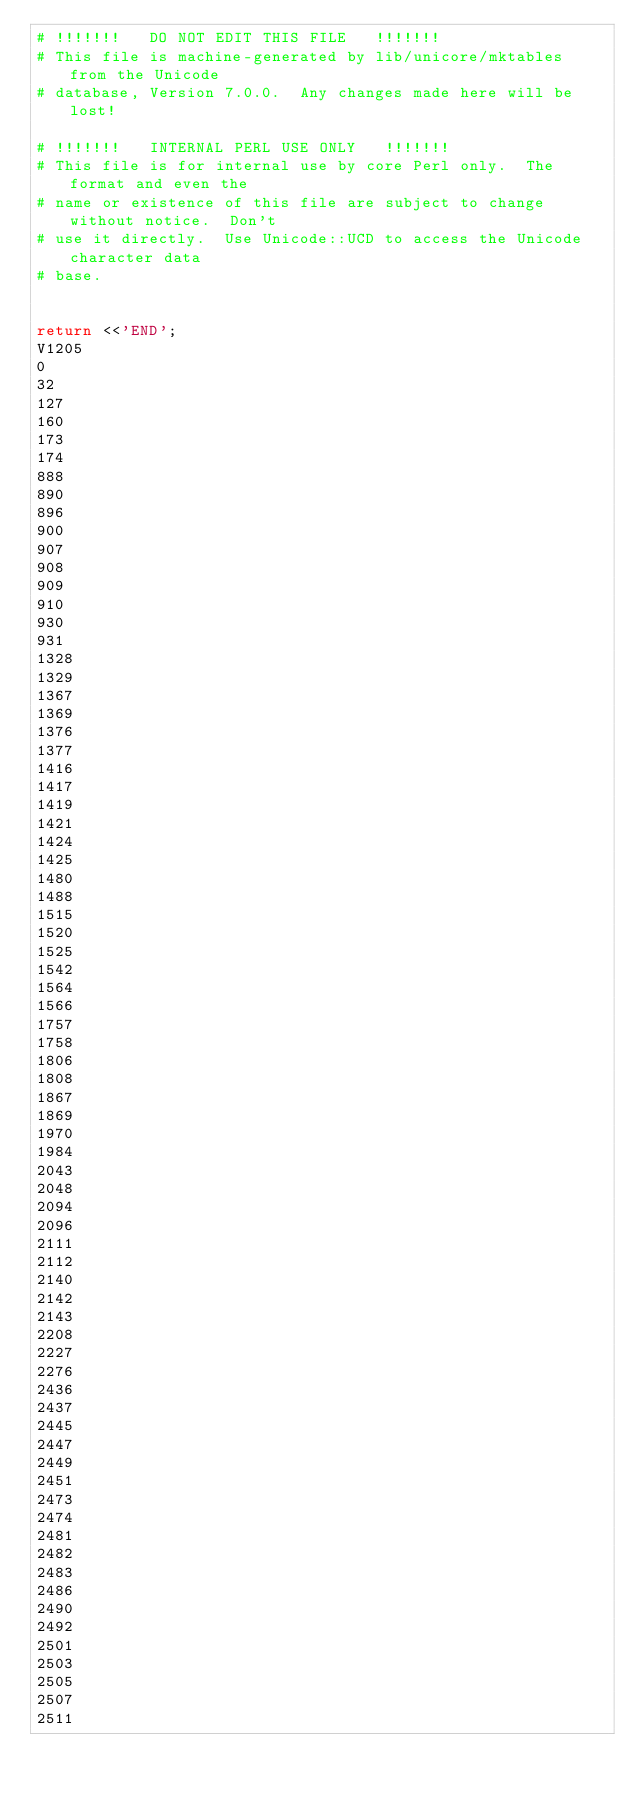<code> <loc_0><loc_0><loc_500><loc_500><_Perl_># !!!!!!!   DO NOT EDIT THIS FILE   !!!!!!!
# This file is machine-generated by lib/unicore/mktables from the Unicode
# database, Version 7.0.0.  Any changes made here will be lost!

# !!!!!!!   INTERNAL PERL USE ONLY   !!!!!!!
# This file is for internal use by core Perl only.  The format and even the
# name or existence of this file are subject to change without notice.  Don't
# use it directly.  Use Unicode::UCD to access the Unicode character data
# base.


return <<'END';
V1205
0
32
127
160
173
174
888
890
896
900
907
908
909
910
930
931
1328
1329
1367
1369
1376
1377
1416
1417
1419
1421
1424
1425
1480
1488
1515
1520
1525
1542
1564
1566
1757
1758
1806
1808
1867
1869
1970
1984
2043
2048
2094
2096
2111
2112
2140
2142
2143
2208
2227
2276
2436
2437
2445
2447
2449
2451
2473
2474
2481
2482
2483
2486
2490
2492
2501
2503
2505
2507
2511</code> 